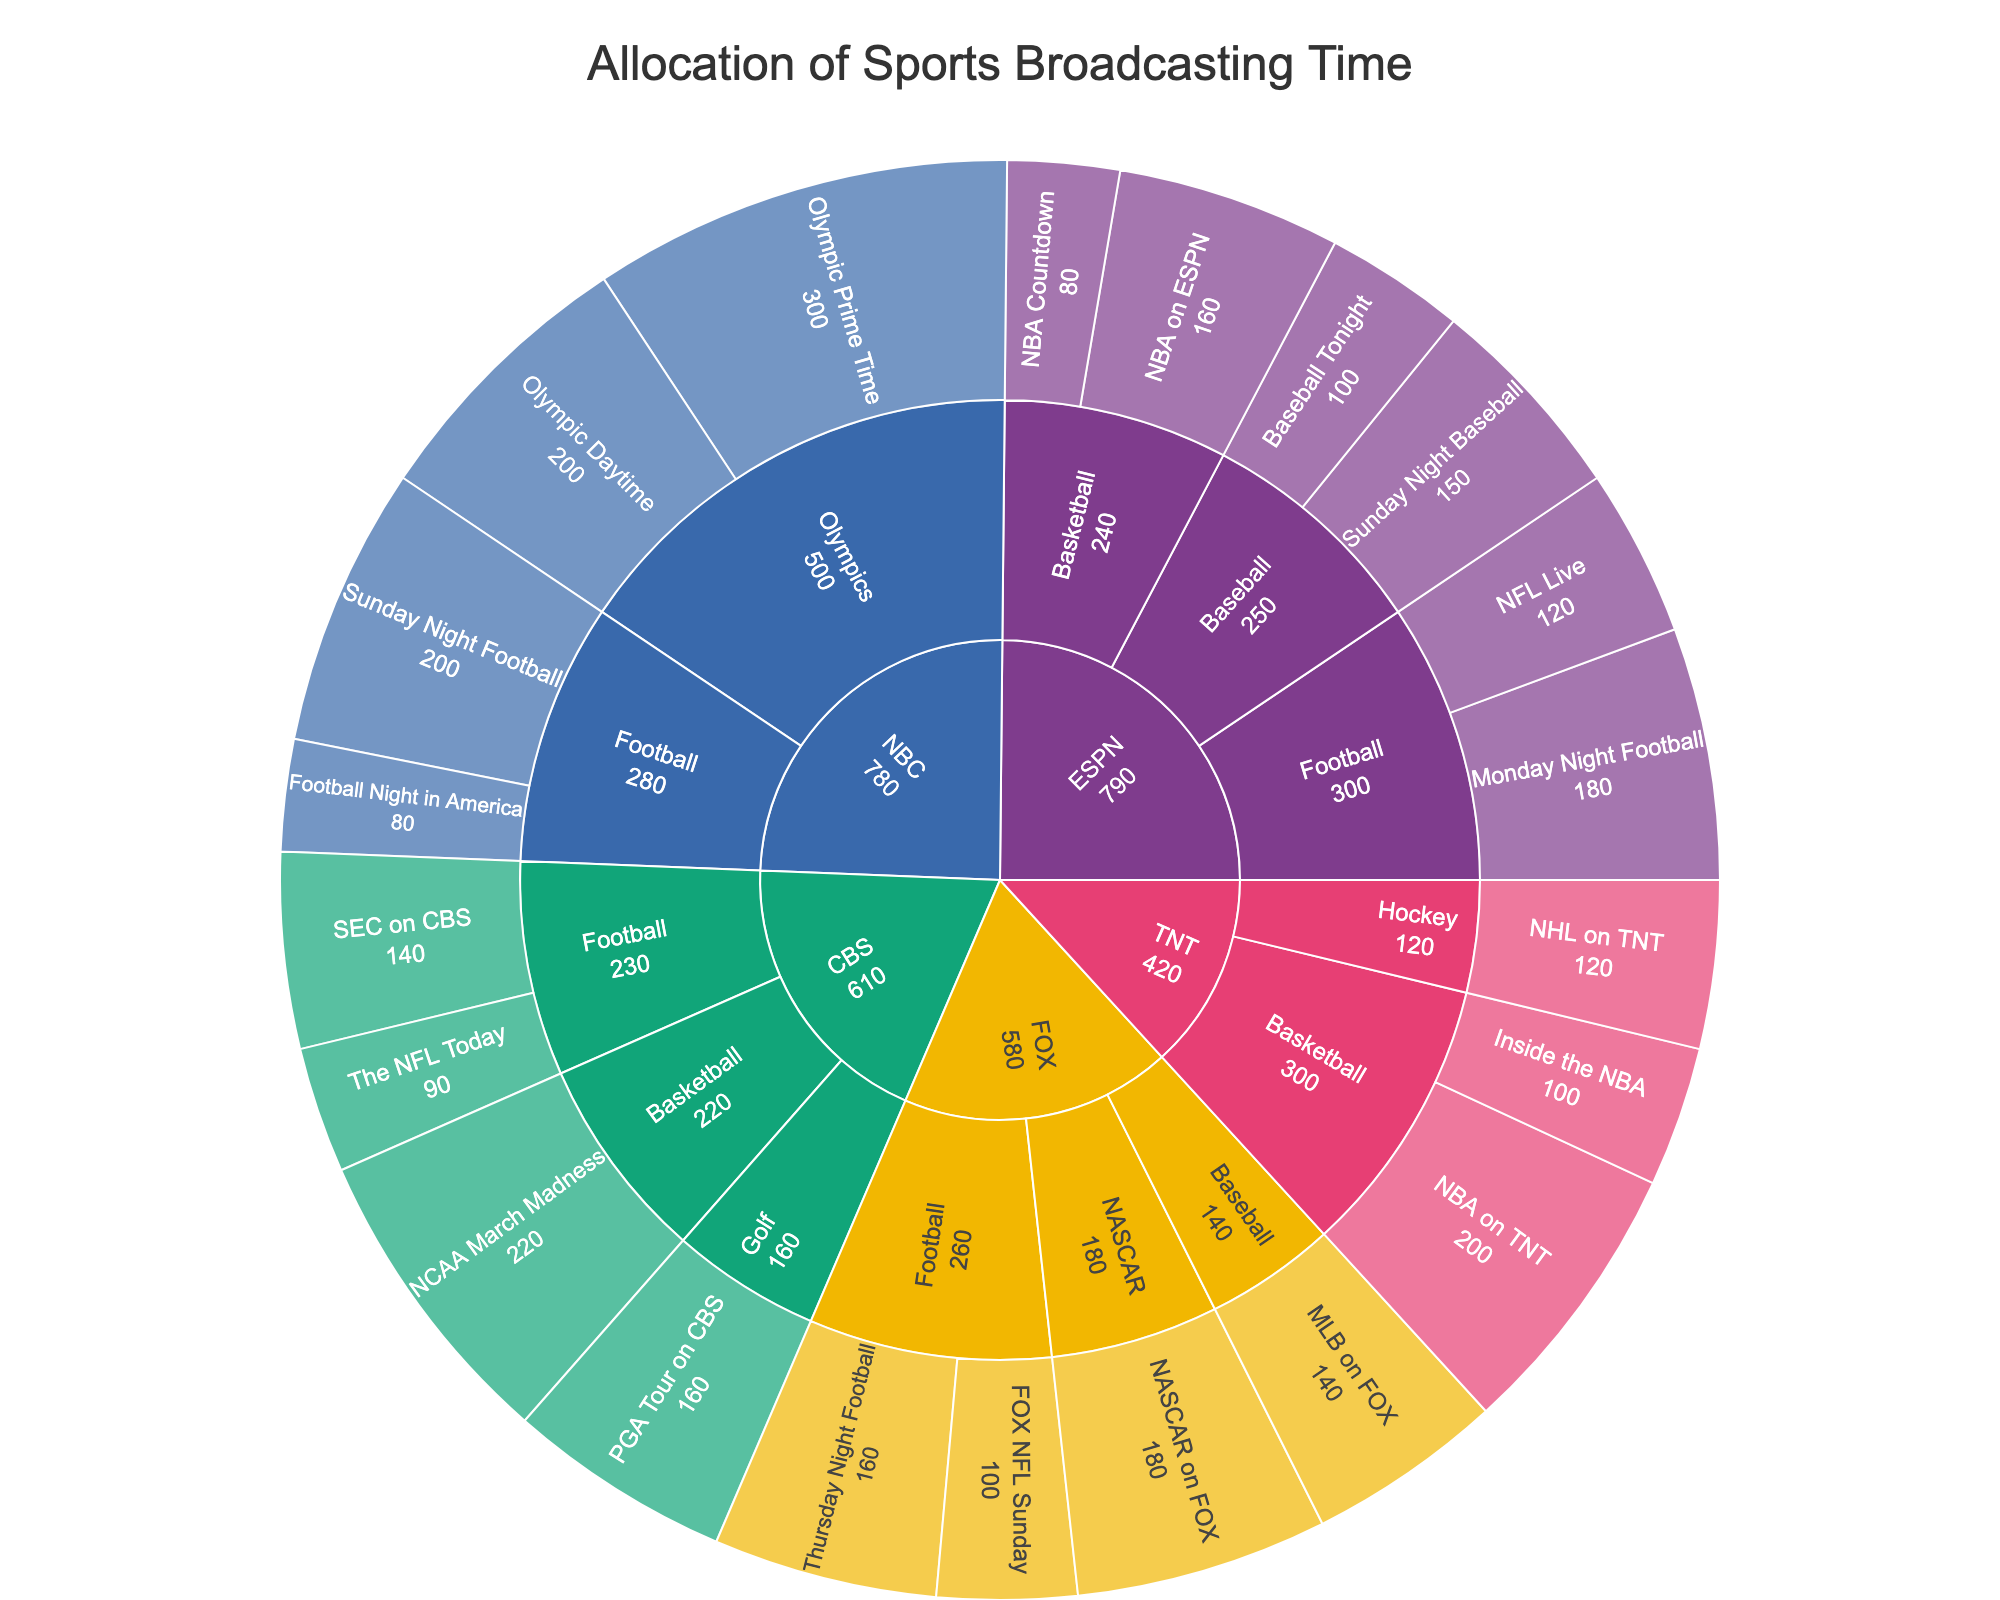What is the title of the plot? The title of the plot is prominently displayed at the top center of the figure. It summarizes the main content being visualized.
Answer: Allocation of Sports Broadcasting Time Which network allocates the most broadcasting hours? By comparing the sizes of the largest segments starting from the center of the sunburst plot, you can identify which network's segment takes up the largest portion.
Answer: NBC How many hours are dedicated to sports on CBS in total? Sum the broadcasting hours of all the programs under CBS by identifying the size of the CBS segment and adding up its sub-segments: "The NFL Today" (90), "SEC on CBS" (140), "NCAA March Madness" (220), and "PGA Tour on CBS" (160).
Answer: 610 Which basketball program on TNT has more broadcasting hours? Identify the two segments under TNT related to basketball: "NBA on TNT" and "Inside the NBA." Then, compare their values.
Answer: NBA on TNT Which network dedicates more time to football, FOX or CBS? Sum the hours dedicated to football under FOX and CBS respectively and compare the totals. FOX has "FOX NFL Sunday" (100) and "Thursday Night Football" (160), while CBS has "The NFL Today" (90) and "SEC on CBS" (140).
Answer: FOX What sport receives the most broadcasting time on NBC? Look at the sub-segments under NBC and compare the hours for each sport. The largest segment within NBC will represent the sport with the most hours.
Answer: Olympics How many more hours does ESPN allocate to baseball compared to basketball? Compare the total hours ESPN allocates to baseball ("Baseball Tonight" (100) and "Sunday Night Baseball" (150)) and basketball ("NBA Countdown" (80) and "NBA on ESPN" (160)), then find the difference.
Answer: 10 What's the combined broadcasting time of all football programs across all networks? Sum all broadcasting hours dedicated to football programs across all networks: ESPN (120+180), NBC (200+80), FOX (100+160), CBS (90+140).
Answer: 1270 Which network covers the widest variety of sports? Identify the network with the most different sports segments within it by examining the branches extending from each network.
Answer: CBS What's the average broadcasting time for programs on TNT? Calculate the average by summing the hours for each program on TNT ("NBA on TNT" (200), "Inside the NBA" (100), "NHL on TNT" (120)) and dividing by the number of programs.
Answer: 140 